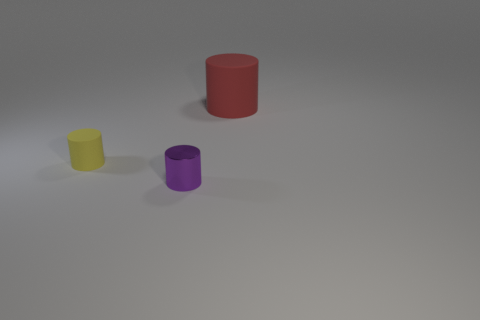Add 1 small cyan metallic cylinders. How many objects exist? 4 Subtract all cubes. Subtract all small metal cylinders. How many objects are left? 2 Add 2 yellow matte cylinders. How many yellow matte cylinders are left? 3 Add 2 big red cylinders. How many big red cylinders exist? 3 Subtract all red cylinders. How many cylinders are left? 2 Subtract all matte cylinders. How many cylinders are left? 1 Subtract 0 green spheres. How many objects are left? 3 Subtract 3 cylinders. How many cylinders are left? 0 Subtract all purple cylinders. Subtract all gray cubes. How many cylinders are left? 2 Subtract all blue balls. How many yellow cylinders are left? 1 